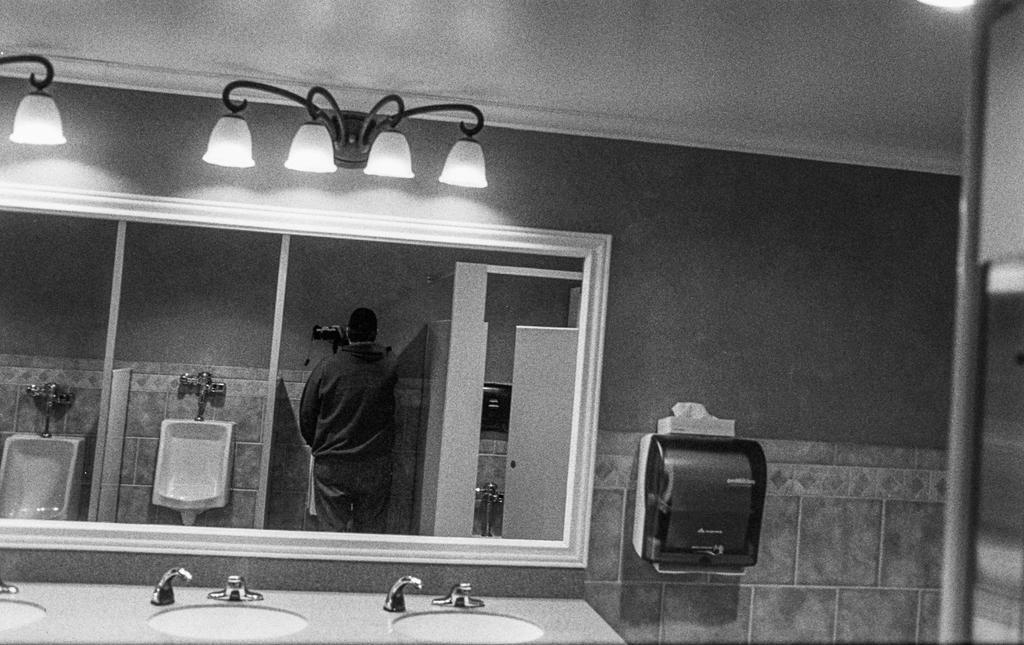In one or two sentences, can you explain what this image depicts? In this picture we can see taps, sinks, toilets, mirror, person standing, lights and some objects and in the background we can see the wall. 